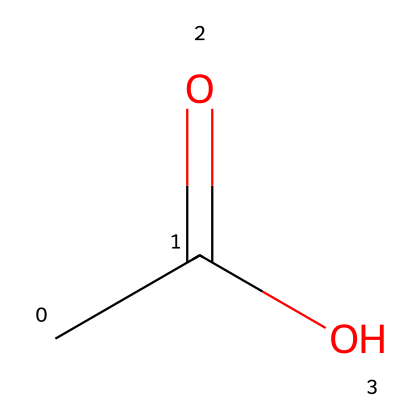What is the molecular formula of this compound? The SMILES representation provided is CC(=O)O. The molecular formula can be derived by counting the number of carbon (C), hydrogen (H), and oxygen (O) atoms in the structure. There are 2 carbon atoms, 4 hydrogen atoms, and 2 oxygen atoms. Thus, the molecular formula is C2H4O2.
Answer: C2H4O2 How many oxygen atoms are in acetic acid? By analyzing the SMILES structure CC(=O)O, we can identify that there are 2 oxygen atoms present in the functional grouping. One oxygen is double bonded to carbon and the other is part of a hydroxyl group.
Answer: 2 What type of functional group is present in this compound? The functional group can be determined by examining the structure CC(=O)O. There is a carboxyl group (-COOH) present, which classifies this compound as a carboxylic acid.
Answer: carboxyl group Is acetic acid a strong or weak acid? To determine whether acetic acid is a strong or weak acid, we need to analyze its dissociation in water. Acetic acid partially dissociates in water rather than fully, which indicates that it is a weak acid.
Answer: weak acid What bond type is found between carbon and oxygen in the carboxylic acid group? The bond type can be determined by looking closely at the structure CC(=O)O. There is a double bond between the carbon and one oxygen atom in the carboxyl group, while the other oxygen is connected through a single bond. Hence, the bond type is a double bond.
Answer: double bond What is the pH range typically associated with acetic acid solutions? Acetic acid solutions typically have a pH range that can be approximated based on their concentration. For dilute solutions of acetic acid, the pH range is generally between 2.4 to 3.4.
Answer: 2.4 to 3.4 